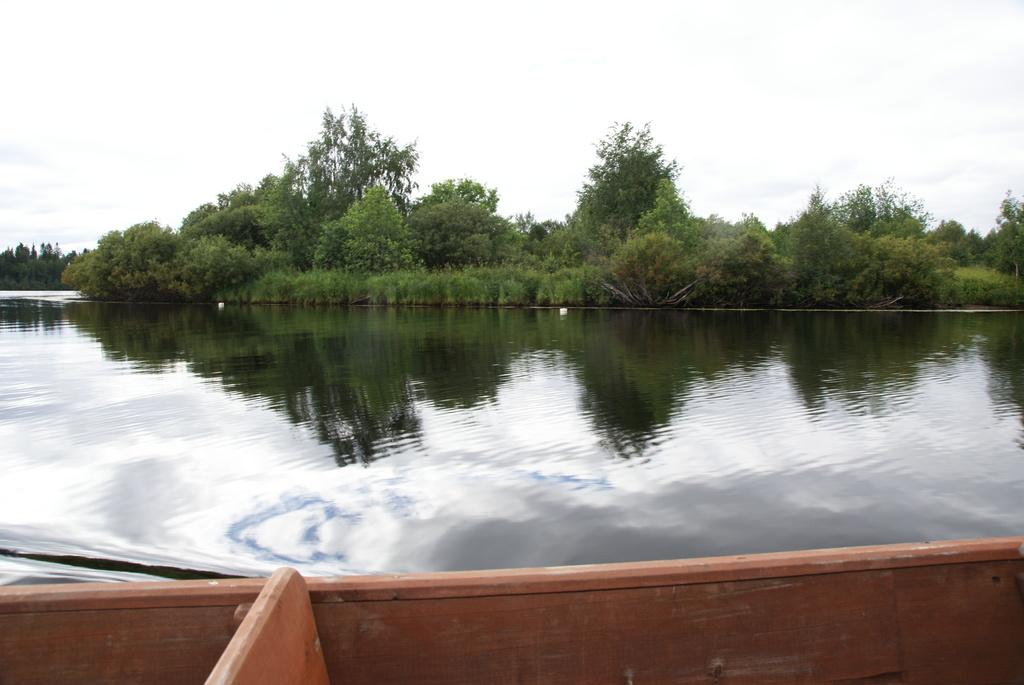What is the primary element in the image? The image consists of water. What can be seen in the background of the image? There are trees in the background of the image. What is visible at the top of the image? The sky is visible at the top of the image. What type of vehicle is present in the image? There is a wooden boat at the bottom of the image. Who is the owner of the cellar in the image? There is no cellar present in the image; it consists of water, trees, sky, and a wooden boat. 